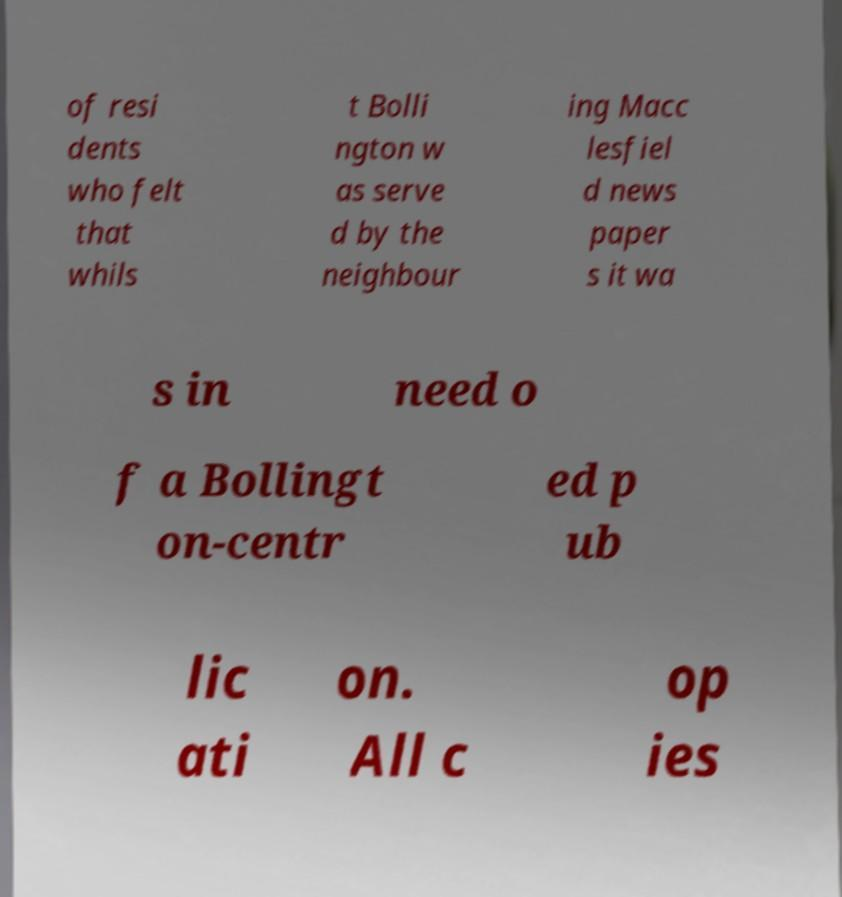I need the written content from this picture converted into text. Can you do that? of resi dents who felt that whils t Bolli ngton w as serve d by the neighbour ing Macc lesfiel d news paper s it wa s in need o f a Bollingt on-centr ed p ub lic ati on. All c op ies 